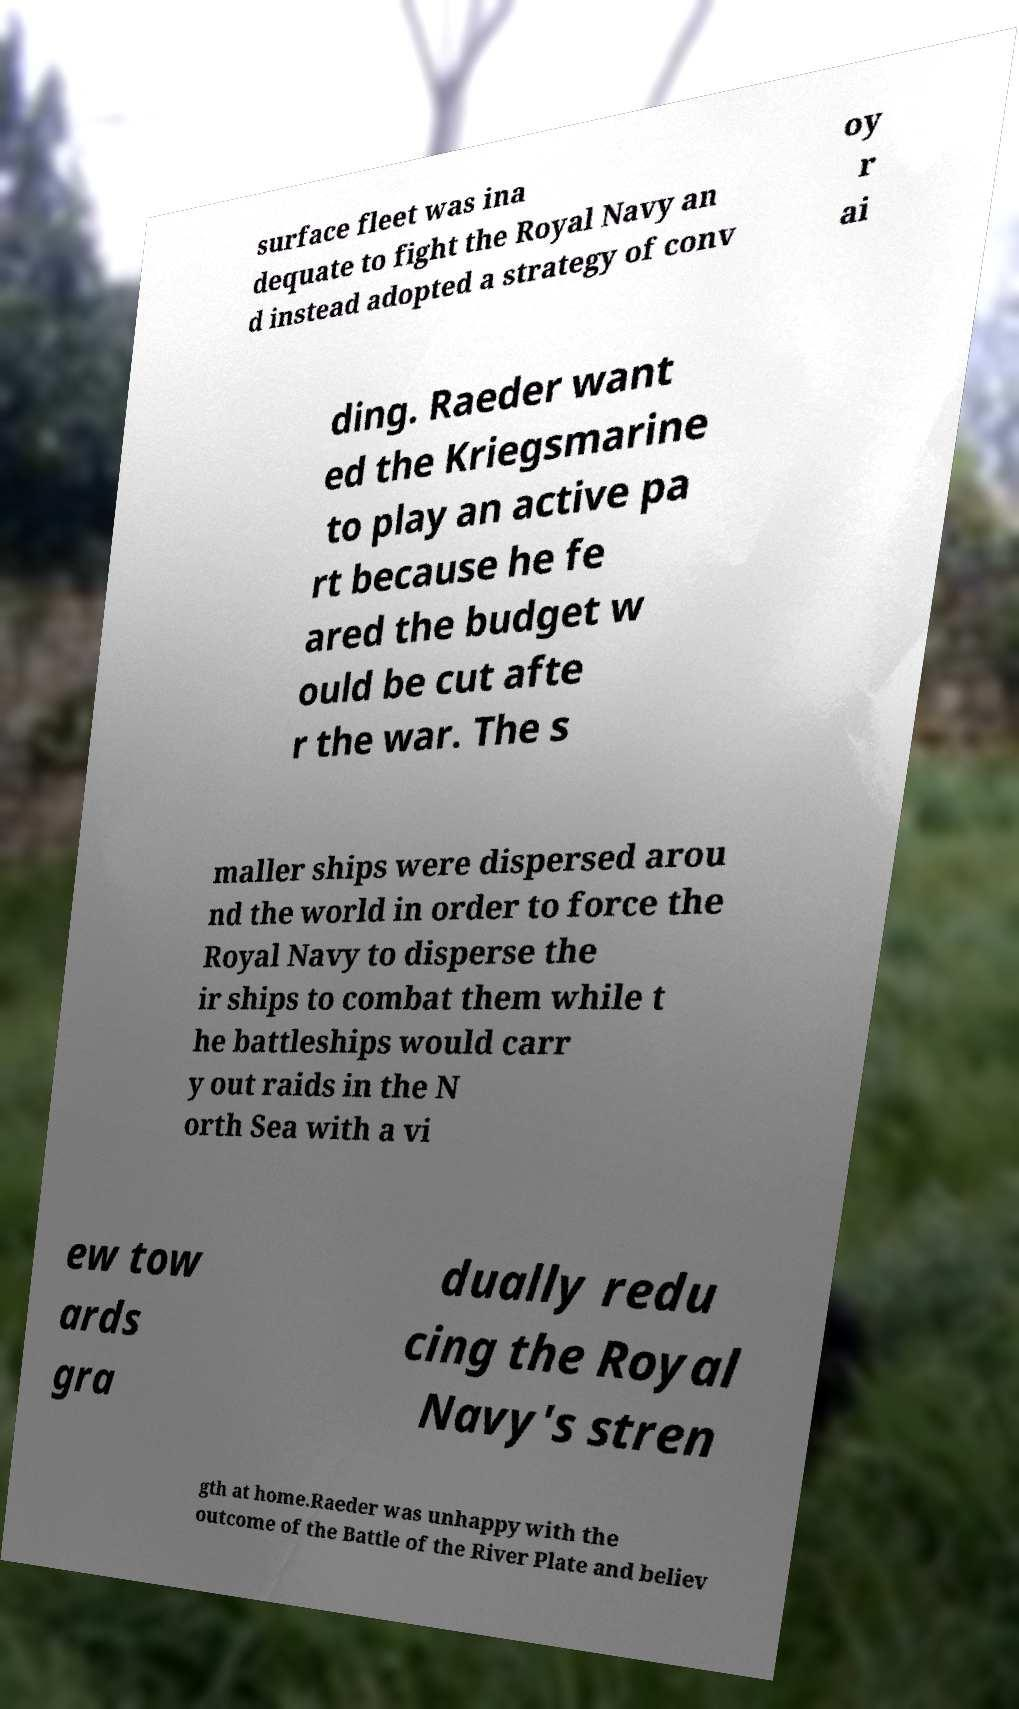Can you accurately transcribe the text from the provided image for me? surface fleet was ina dequate to fight the Royal Navy an d instead adopted a strategy of conv oy r ai ding. Raeder want ed the Kriegsmarine to play an active pa rt because he fe ared the budget w ould be cut afte r the war. The s maller ships were dispersed arou nd the world in order to force the Royal Navy to disperse the ir ships to combat them while t he battleships would carr y out raids in the N orth Sea with a vi ew tow ards gra dually redu cing the Royal Navy's stren gth at home.Raeder was unhappy with the outcome of the Battle of the River Plate and believ 